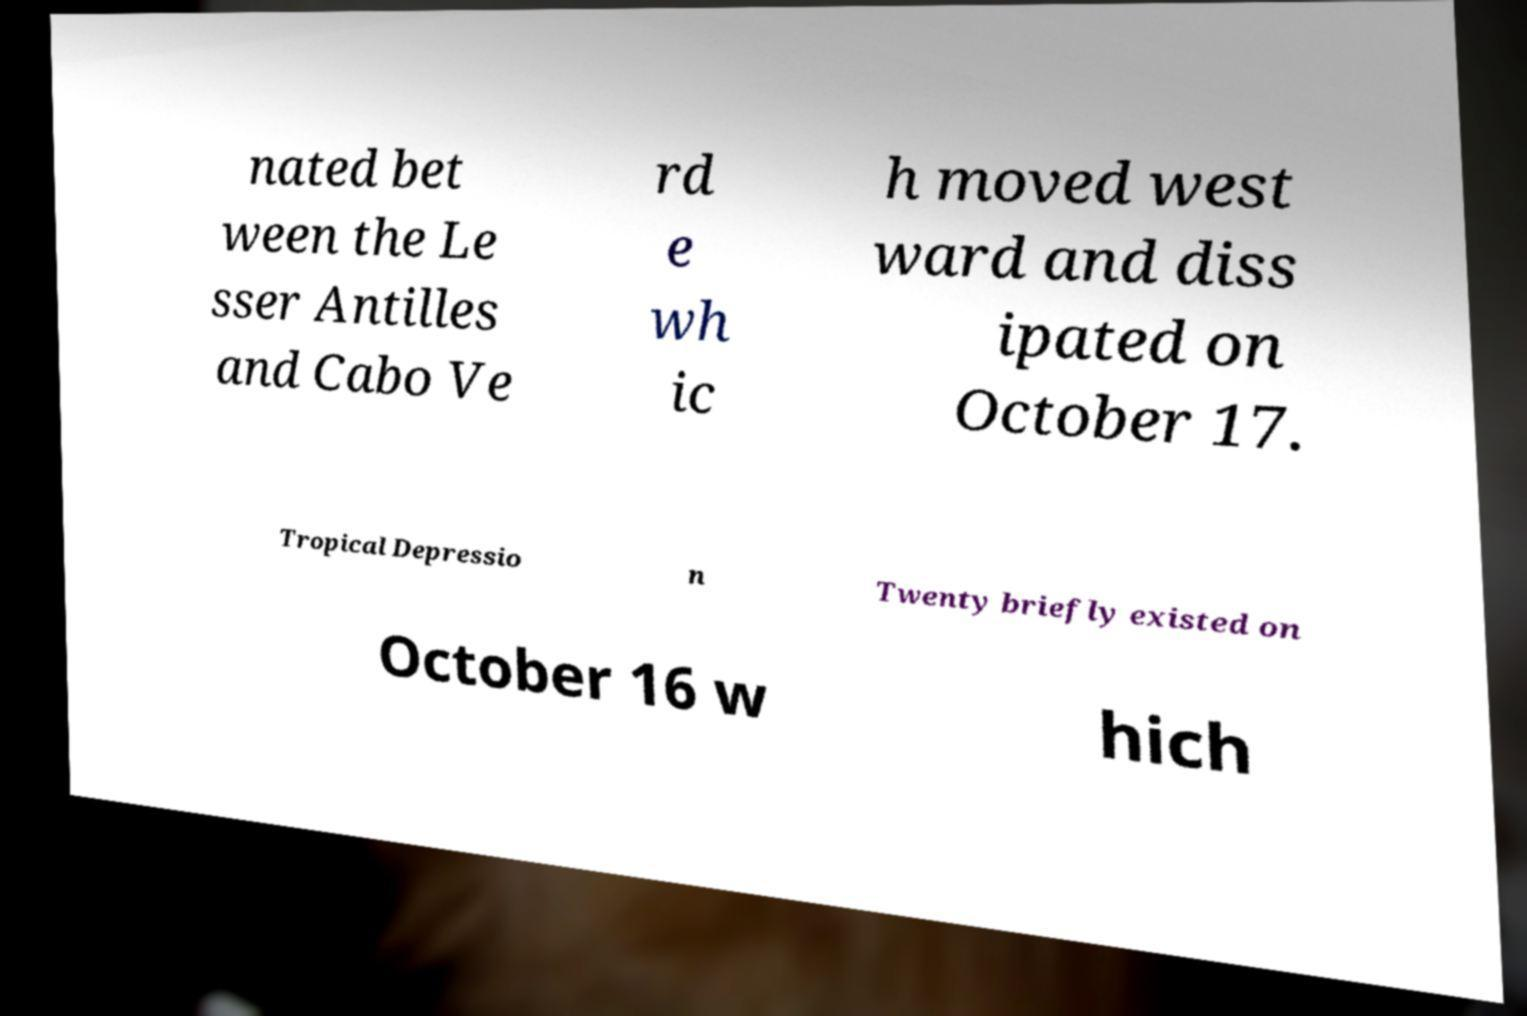Could you assist in decoding the text presented in this image and type it out clearly? nated bet ween the Le sser Antilles and Cabo Ve rd e wh ic h moved west ward and diss ipated on October 17. Tropical Depressio n Twenty briefly existed on October 16 w hich 